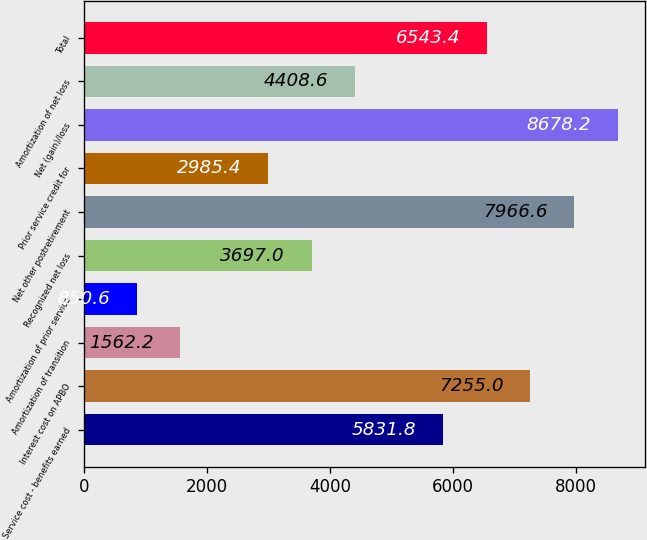Convert chart to OTSL. <chart><loc_0><loc_0><loc_500><loc_500><bar_chart><fcel>Service cost - benefits earned<fcel>Interest cost on APBO<fcel>Amortization of transition<fcel>Amortization of prior service<fcel>Recognized net loss<fcel>Net other postretirement<fcel>Prior service credit for<fcel>Net (gain)/loss<fcel>Amortization of net loss<fcel>Total<nl><fcel>5831.8<fcel>7255<fcel>1562.2<fcel>850.6<fcel>3697<fcel>7966.6<fcel>2985.4<fcel>8678.2<fcel>4408.6<fcel>6543.4<nl></chart> 